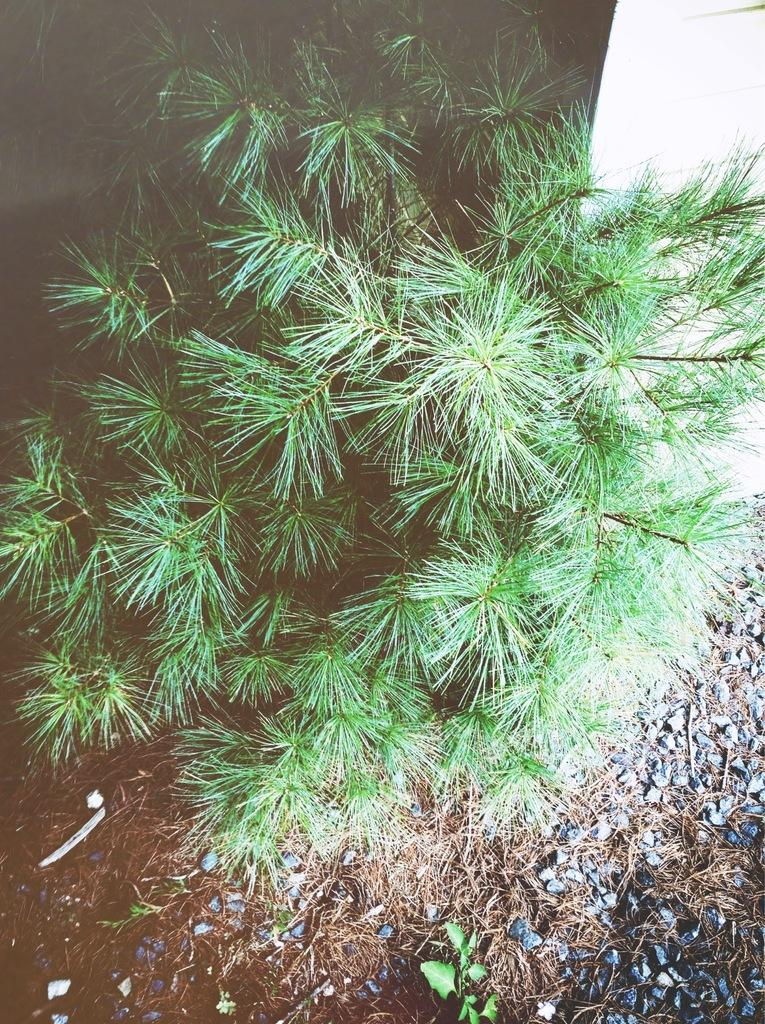What is present in the foreground of the image? There are gravels and dry grass in the foreground of the image. What type of grass is visible in the center of the image? There is green grass in the center of the image. What can be seen in the background of the image? There appears to be a wall in the background of the image. What type of linen is draped over the wall in the image? There is no linen present in the image; the wall is visible without any fabric or textile draped over it. How many sponges can be seen on the wall in the image? There are no sponges present in the image; the wall is the only architectural feature visible. 